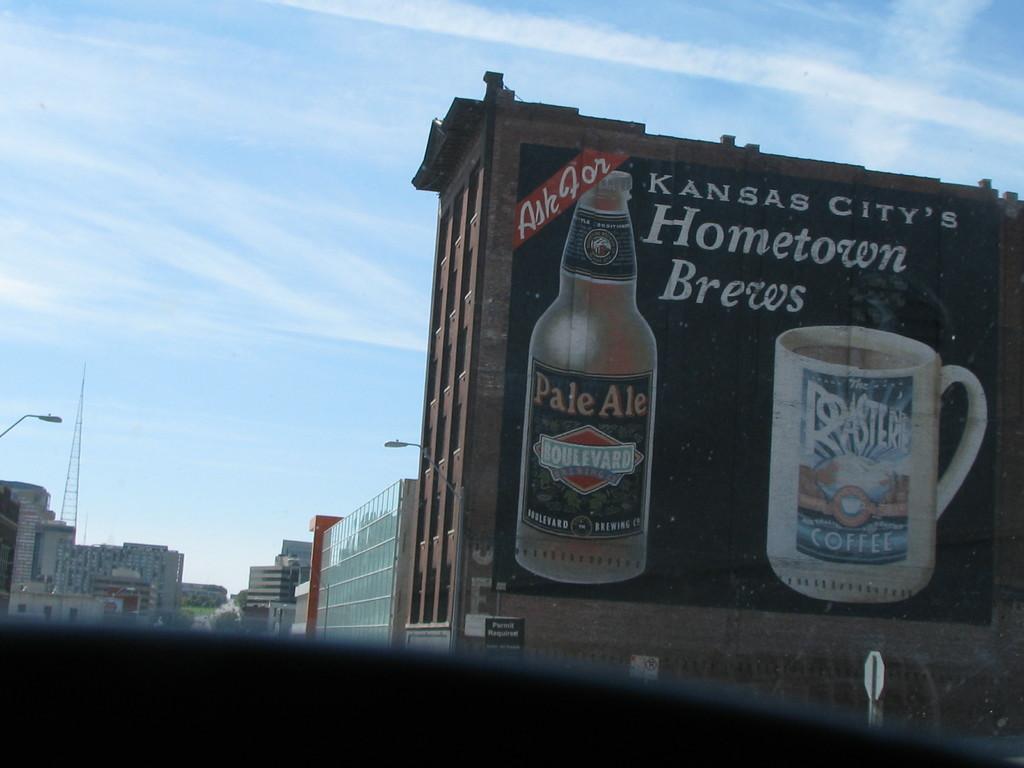Are these hometown brews?
Ensure brevity in your answer.  Yes. What is the brand of beer?
Give a very brief answer. Boulevard. 